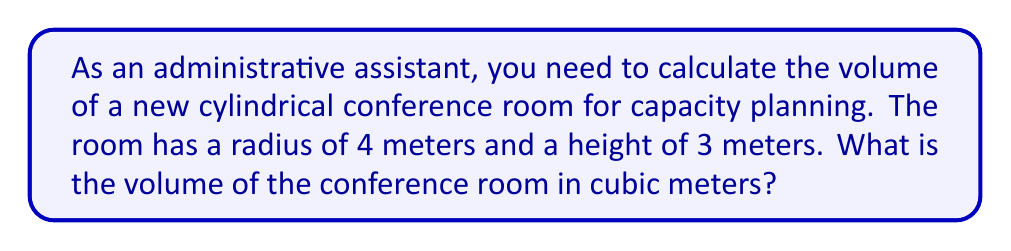What is the answer to this math problem? To calculate the volume of a cylinder, we use the formula:

$$V = \pi r^2 h$$

Where:
$V$ = volume
$r$ = radius of the base
$h$ = height of the cylinder

Given:
$r = 4$ meters
$h = 3$ meters

Let's substitute these values into the formula:

$$V = \pi (4 \text{ m})^2 (3 \text{ m})$$

$$V = \pi (16 \text{ m}^2) (3 \text{ m})$$

$$V = 48\pi \text{ m}^3$$

Now, let's calculate the approximate value using $\pi \approx 3.14159$:

$$V \approx 48 \times 3.14159 \text{ m}^3$$

$$V \approx 150.80 \text{ m}^3$$

Therefore, the volume of the cylindrical conference room is approximately 150.80 cubic meters.

[asy]
import three;
size(200);
currentprojection=perspective(6,3,2);
real r=4, h=3;
draw(surface(circle((0,0,0),r)),blue+opacity(0.2));
draw(surface(circle((0,0,h),r)),blue+opacity(0.2));
path3 p=circle((0,0,0),r);
for(int i=0; i<360; i+=30) {
  draw((r*cos(i),r*sin(i),0)--(r*cos(i),r*sin(i),h));
}
draw(p);
draw(shift(0,0,h)*p);
label("r=4m",(r,0,0),E);
label("h=3m",(r,0,h/2),E);
[/asy]
Answer: $150.80 \text{ m}^3$ 